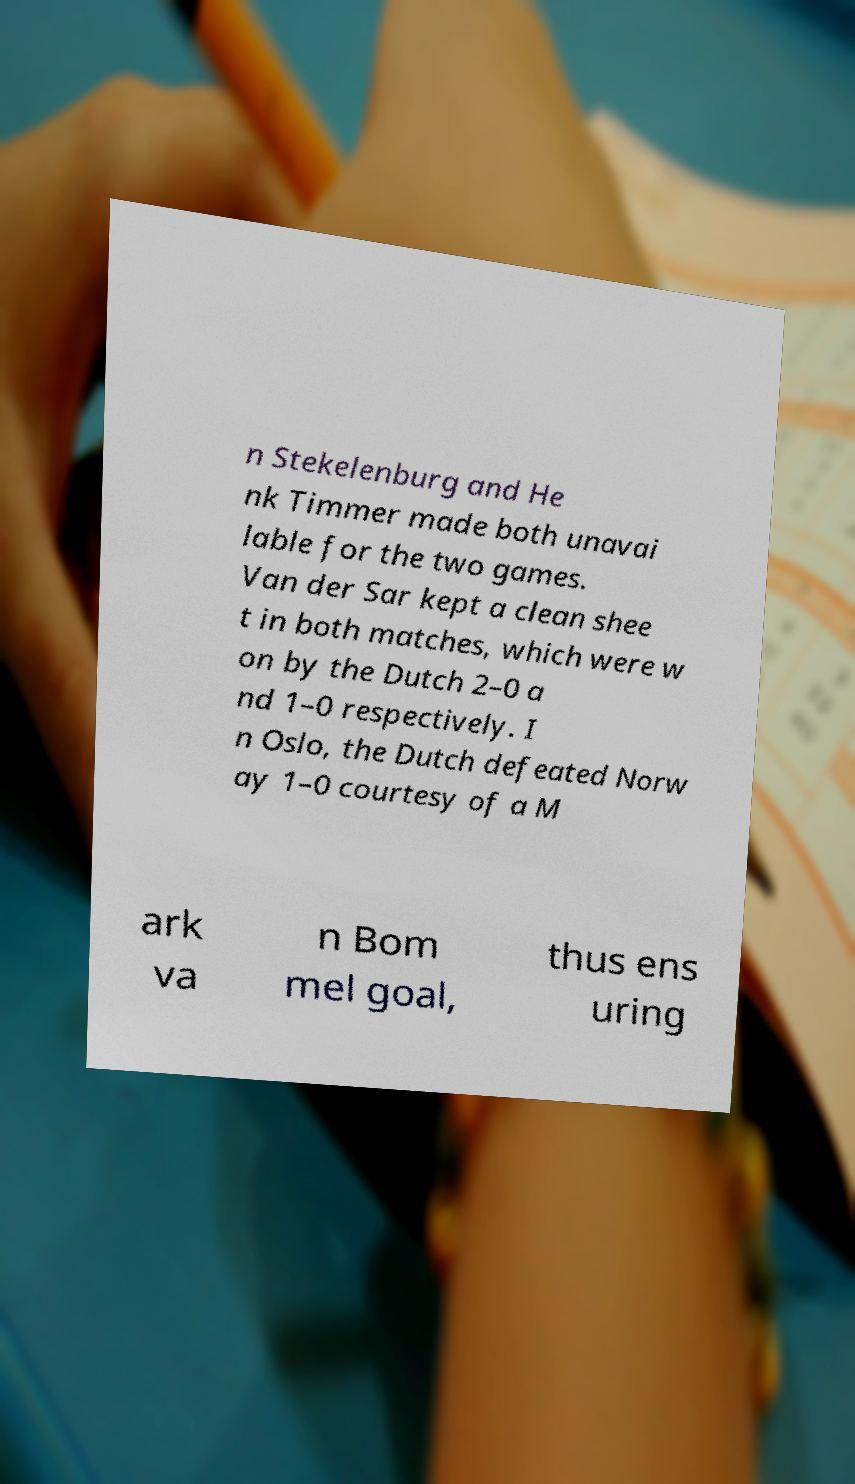Could you assist in decoding the text presented in this image and type it out clearly? n Stekelenburg and He nk Timmer made both unavai lable for the two games. Van der Sar kept a clean shee t in both matches, which were w on by the Dutch 2–0 a nd 1–0 respectively. I n Oslo, the Dutch defeated Norw ay 1–0 courtesy of a M ark va n Bom mel goal, thus ens uring 